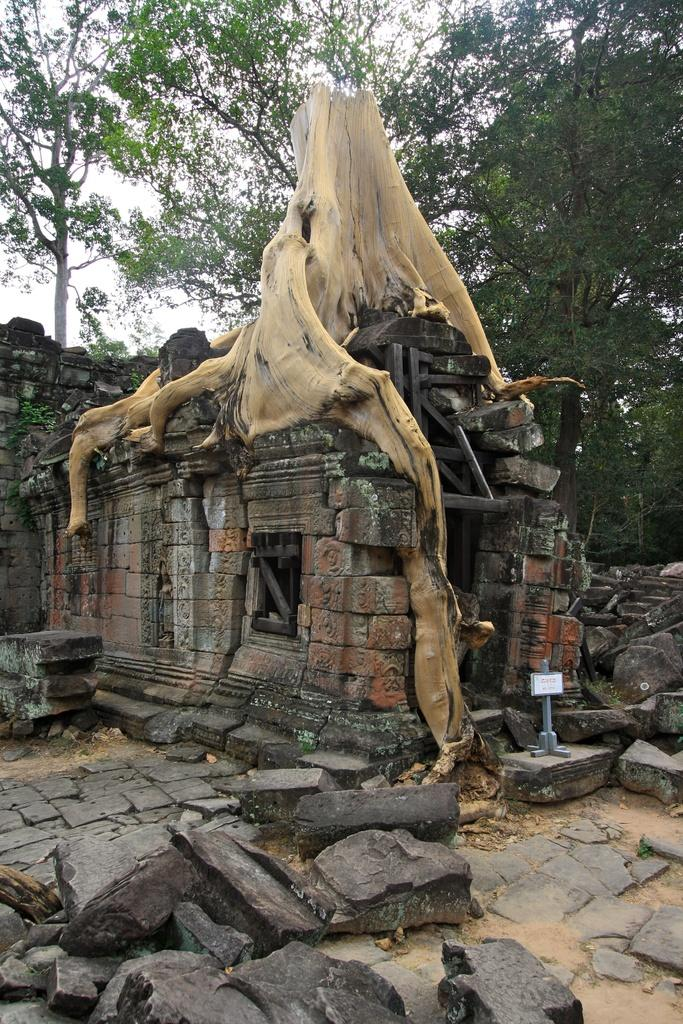What type of vegetation can be seen in the image? There are trees in the image. What type of structure is present in the image? There is a temple in the image. What is the central object in the image? There is a stem in the middle of the image. What type of natural formation is visible at the bottom of the image? There are rocks at the bottom of the image. Is there a bag filled with poison visible in the image? No, there is no bag or poison present in the image. Can you see a railway track in the image? No, there is no railway track visible in the image. 